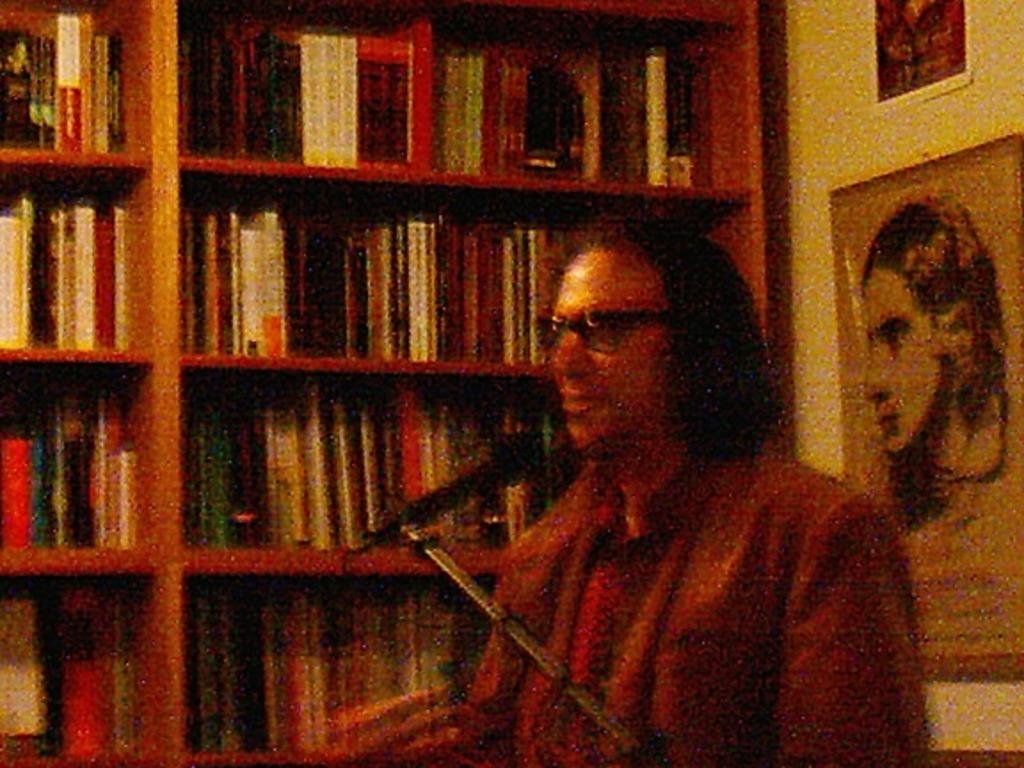Provide a one-sentence caption for the provided image. A man with glasses talking into a microphone in front of a book shelf. 